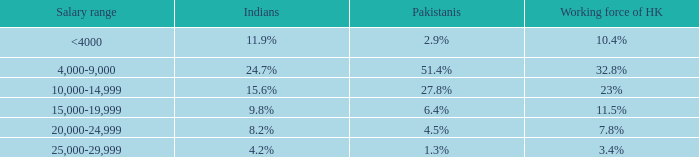2%, what is the wage range? 20,000-24,999. 